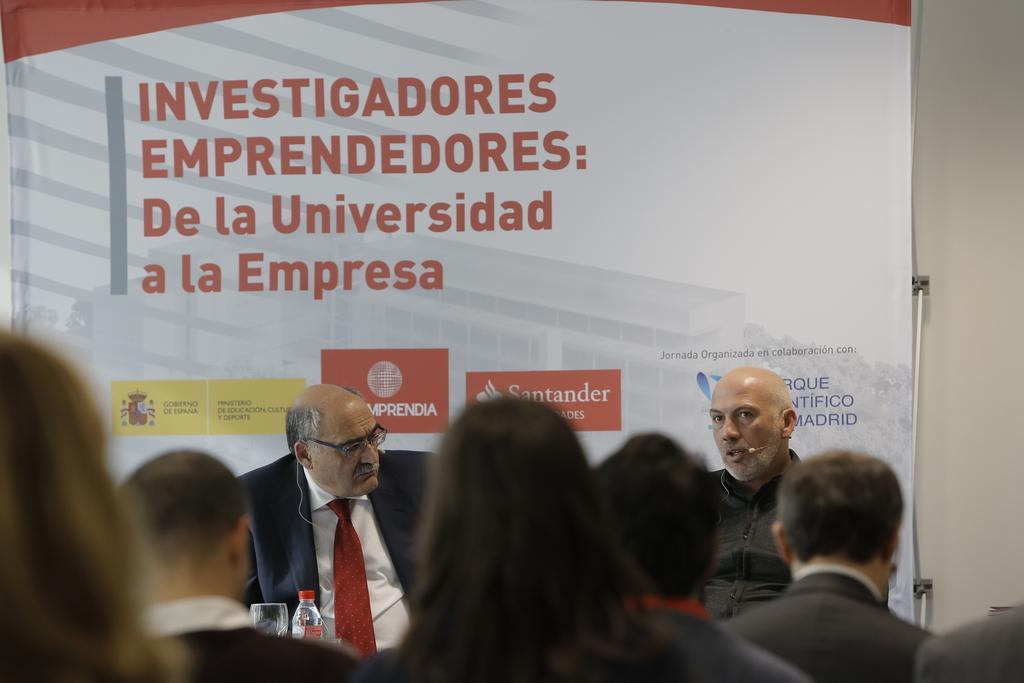Describe this image in one or two sentences. In this picture, there are people at the bottom. Only two persons facing forward, remaining are facing backwards. At the bottom, there is a person wearing blazer, white shirt and tie. Before him, there is a glass and a bottle. Towards the right, there is another man wearing black shirt. Before them, there are people. In the background, there is a board with some text and pictures. 